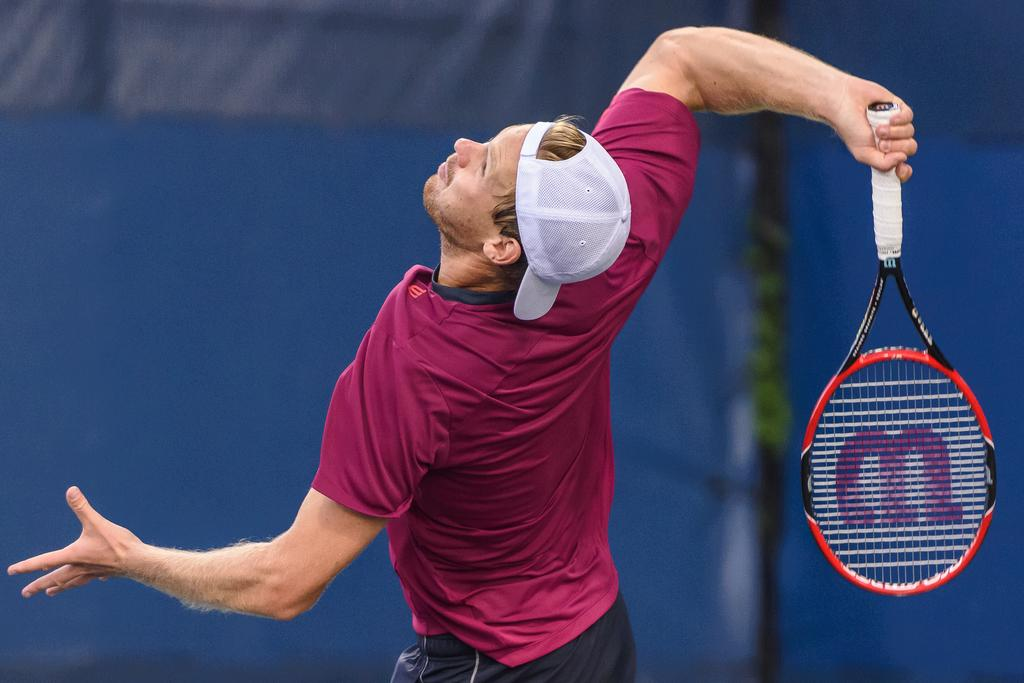Who is present in the image? There is a man in the image. What is the man wearing on his head? The man is wearing a cap. What object is the man holding in the image? The man is holding a tennis racket. What can be seen in the background of the image? There are clothes visible in the background of the image. What type of nerve is being discussed in the caption of the image? There is no caption present in the image, and therefore no discussion of a nerve. 